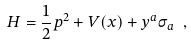Convert formula to latex. <formula><loc_0><loc_0><loc_500><loc_500>H = \frac { 1 } { 2 } p ^ { 2 } + V ( x ) + y ^ { a } \sigma _ { a } \ ,</formula> 